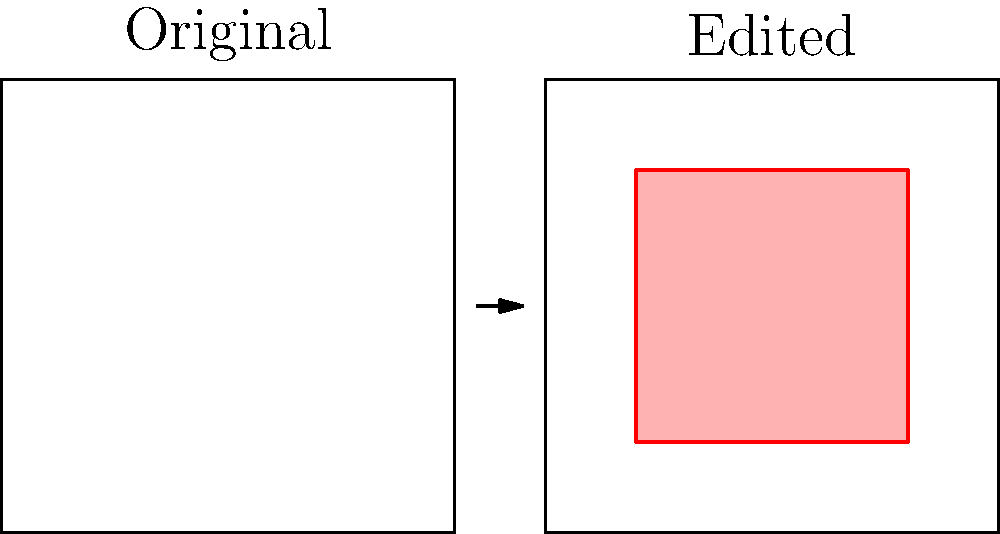As an editor-in-chief, you receive a press release with before and after images of a product. The 'after' image shows significant improvements, but you suspect digital manipulation. Which area of the image should you scrutinize most closely for potential alterations? To identify potential manipulation in press release images, follow these steps:

1. Compare the 'before' and 'after' images side by side.
2. Look for areas with dramatic changes or improvements.
3. Pay attention to areas with unusually smooth textures or perfect edges.
4. Examine the lighting and shadows for consistency.
5. Check for any distortions or warping in the background.
6. Focus on areas that are crucial to the product's claimed improvements.

In this case, the red-highlighted area in the 'after' image shows the most significant changes. This area is likely where the product's improvements are meant to be showcased, making it the prime target for potential manipulation. As an editor-in-chief relying on press releases, it's crucial to scrutinize this area carefully to ensure the integrity of the news you publish.
Answer: The red-highlighted area in the 'after' image 